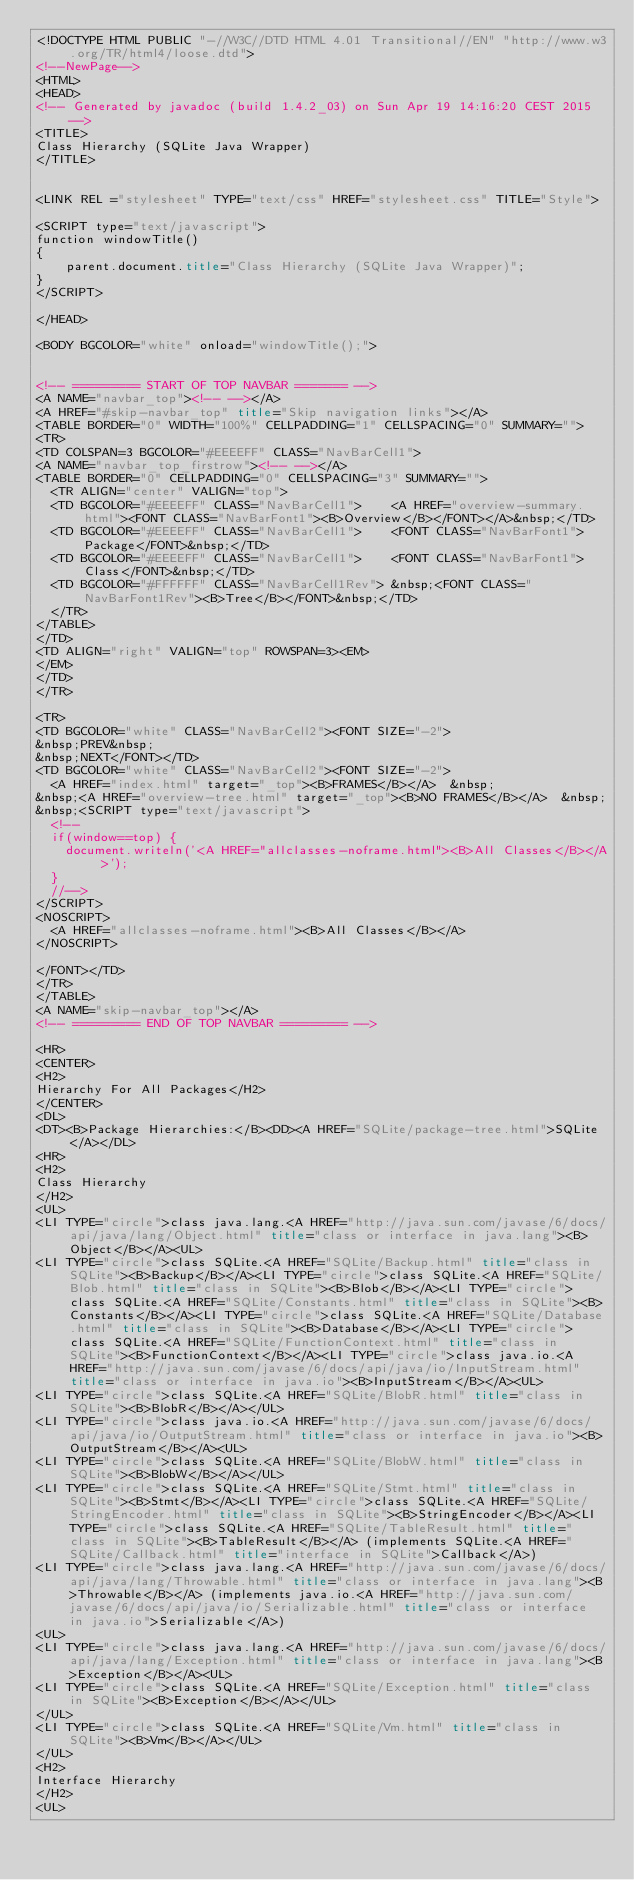Convert code to text. <code><loc_0><loc_0><loc_500><loc_500><_HTML_><!DOCTYPE HTML PUBLIC "-//W3C//DTD HTML 4.01 Transitional//EN" "http://www.w3.org/TR/html4/loose.dtd">
<!--NewPage-->
<HTML>
<HEAD>
<!-- Generated by javadoc (build 1.4.2_03) on Sun Apr 19 14:16:20 CEST 2015 -->
<TITLE>
Class Hierarchy (SQLite Java Wrapper)
</TITLE>


<LINK REL ="stylesheet" TYPE="text/css" HREF="stylesheet.css" TITLE="Style">

<SCRIPT type="text/javascript">
function windowTitle()
{
    parent.document.title="Class Hierarchy (SQLite Java Wrapper)";
}
</SCRIPT>

</HEAD>

<BODY BGCOLOR="white" onload="windowTitle();">


<!-- ========= START OF TOP NAVBAR ======= -->
<A NAME="navbar_top"><!-- --></A>
<A HREF="#skip-navbar_top" title="Skip navigation links"></A>
<TABLE BORDER="0" WIDTH="100%" CELLPADDING="1" CELLSPACING="0" SUMMARY="">
<TR>
<TD COLSPAN=3 BGCOLOR="#EEEEFF" CLASS="NavBarCell1">
<A NAME="navbar_top_firstrow"><!-- --></A>
<TABLE BORDER="0" CELLPADDING="0" CELLSPACING="3" SUMMARY="">
  <TR ALIGN="center" VALIGN="top">
  <TD BGCOLOR="#EEEEFF" CLASS="NavBarCell1">    <A HREF="overview-summary.html"><FONT CLASS="NavBarFont1"><B>Overview</B></FONT></A>&nbsp;</TD>
  <TD BGCOLOR="#EEEEFF" CLASS="NavBarCell1">    <FONT CLASS="NavBarFont1">Package</FONT>&nbsp;</TD>
  <TD BGCOLOR="#EEEEFF" CLASS="NavBarCell1">    <FONT CLASS="NavBarFont1">Class</FONT>&nbsp;</TD>
  <TD BGCOLOR="#FFFFFF" CLASS="NavBarCell1Rev"> &nbsp;<FONT CLASS="NavBarFont1Rev"><B>Tree</B></FONT>&nbsp;</TD>
  </TR>
</TABLE>
</TD>
<TD ALIGN="right" VALIGN="top" ROWSPAN=3><EM>
</EM>
</TD>
</TR>

<TR>
<TD BGCOLOR="white" CLASS="NavBarCell2"><FONT SIZE="-2">
&nbsp;PREV&nbsp;
&nbsp;NEXT</FONT></TD>
<TD BGCOLOR="white" CLASS="NavBarCell2"><FONT SIZE="-2">
  <A HREF="index.html" target="_top"><B>FRAMES</B></A>  &nbsp;
&nbsp;<A HREF="overview-tree.html" target="_top"><B>NO FRAMES</B></A>  &nbsp;
&nbsp;<SCRIPT type="text/javascript">
  <!--
  if(window==top) {
    document.writeln('<A HREF="allclasses-noframe.html"><B>All Classes</B></A>');
  }
  //-->
</SCRIPT>
<NOSCRIPT>
  <A HREF="allclasses-noframe.html"><B>All Classes</B></A>
</NOSCRIPT>

</FONT></TD>
</TR>
</TABLE>
<A NAME="skip-navbar_top"></A>
<!-- ========= END OF TOP NAVBAR ========= -->

<HR>
<CENTER>
<H2>
Hierarchy For All Packages</H2>
</CENTER>
<DL>
<DT><B>Package Hierarchies:</B><DD><A HREF="SQLite/package-tree.html">SQLite</A></DL>
<HR>
<H2>
Class Hierarchy
</H2>
<UL>
<LI TYPE="circle">class java.lang.<A HREF="http://java.sun.com/javase/6/docs/api/java/lang/Object.html" title="class or interface in java.lang"><B>Object</B></A><UL>
<LI TYPE="circle">class SQLite.<A HREF="SQLite/Backup.html" title="class in SQLite"><B>Backup</B></A><LI TYPE="circle">class SQLite.<A HREF="SQLite/Blob.html" title="class in SQLite"><B>Blob</B></A><LI TYPE="circle">class SQLite.<A HREF="SQLite/Constants.html" title="class in SQLite"><B>Constants</B></A><LI TYPE="circle">class SQLite.<A HREF="SQLite/Database.html" title="class in SQLite"><B>Database</B></A><LI TYPE="circle">class SQLite.<A HREF="SQLite/FunctionContext.html" title="class in SQLite"><B>FunctionContext</B></A><LI TYPE="circle">class java.io.<A HREF="http://java.sun.com/javase/6/docs/api/java/io/InputStream.html" title="class or interface in java.io"><B>InputStream</B></A><UL>
<LI TYPE="circle">class SQLite.<A HREF="SQLite/BlobR.html" title="class in SQLite"><B>BlobR</B></A></UL>
<LI TYPE="circle">class java.io.<A HREF="http://java.sun.com/javase/6/docs/api/java/io/OutputStream.html" title="class or interface in java.io"><B>OutputStream</B></A><UL>
<LI TYPE="circle">class SQLite.<A HREF="SQLite/BlobW.html" title="class in SQLite"><B>BlobW</B></A></UL>
<LI TYPE="circle">class SQLite.<A HREF="SQLite/Stmt.html" title="class in SQLite"><B>Stmt</B></A><LI TYPE="circle">class SQLite.<A HREF="SQLite/StringEncoder.html" title="class in SQLite"><B>StringEncoder</B></A><LI TYPE="circle">class SQLite.<A HREF="SQLite/TableResult.html" title="class in SQLite"><B>TableResult</B></A> (implements SQLite.<A HREF="SQLite/Callback.html" title="interface in SQLite">Callback</A>)
<LI TYPE="circle">class java.lang.<A HREF="http://java.sun.com/javase/6/docs/api/java/lang/Throwable.html" title="class or interface in java.lang"><B>Throwable</B></A> (implements java.io.<A HREF="http://java.sun.com/javase/6/docs/api/java/io/Serializable.html" title="class or interface in java.io">Serializable</A>)
<UL>
<LI TYPE="circle">class java.lang.<A HREF="http://java.sun.com/javase/6/docs/api/java/lang/Exception.html" title="class or interface in java.lang"><B>Exception</B></A><UL>
<LI TYPE="circle">class SQLite.<A HREF="SQLite/Exception.html" title="class in SQLite"><B>Exception</B></A></UL>
</UL>
<LI TYPE="circle">class SQLite.<A HREF="SQLite/Vm.html" title="class in SQLite"><B>Vm</B></A></UL>
</UL>
<H2>
Interface Hierarchy
</H2>
<UL></code> 